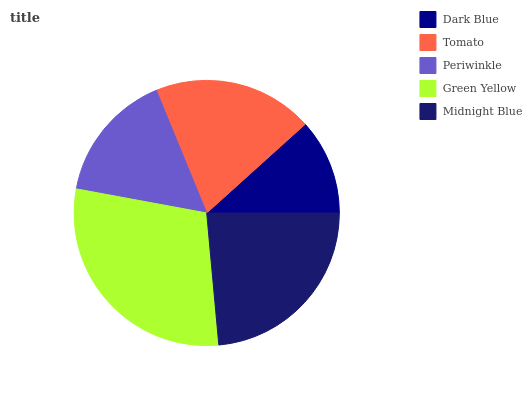Is Dark Blue the minimum?
Answer yes or no. Yes. Is Green Yellow the maximum?
Answer yes or no. Yes. Is Tomato the minimum?
Answer yes or no. No. Is Tomato the maximum?
Answer yes or no. No. Is Tomato greater than Dark Blue?
Answer yes or no. Yes. Is Dark Blue less than Tomato?
Answer yes or no. Yes. Is Dark Blue greater than Tomato?
Answer yes or no. No. Is Tomato less than Dark Blue?
Answer yes or no. No. Is Tomato the high median?
Answer yes or no. Yes. Is Tomato the low median?
Answer yes or no. Yes. Is Periwinkle the high median?
Answer yes or no. No. Is Dark Blue the low median?
Answer yes or no. No. 